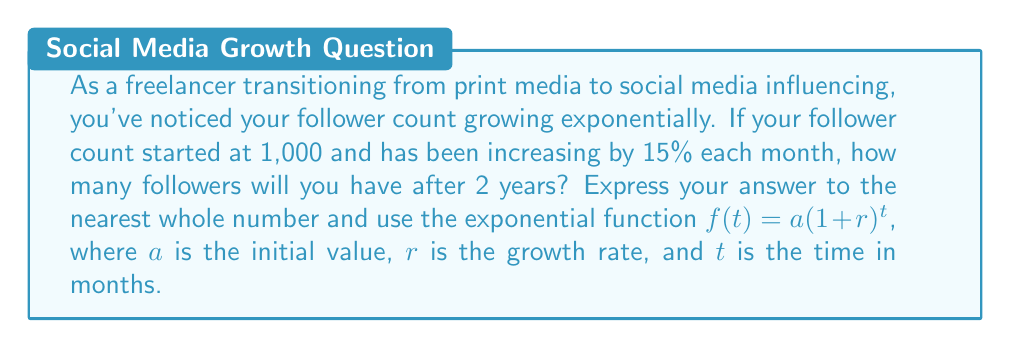Solve this math problem. Let's approach this step-by-step:

1) We're given:
   - Initial follower count, $a = 1,000$
   - Monthly growth rate, $r = 15\% = 0.15$
   - Time period, $t = 2$ years $= 24$ months

2) We'll use the exponential growth function:
   $f(t) = a(1+r)^t$

3) Substituting our values:
   $f(24) = 1000(1+0.15)^{24}$

4) Simplify inside the parentheses:
   $f(24) = 1000(1.15)^{24}$

5) Calculate $(1.15)^{24}$:
   $(1.15)^{24} \approx 31.772261...$

6) Multiply by 1000:
   $f(24) = 1000 * 31.772261... = 31,772.261...$

7) Rounding to the nearest whole number:
   $f(24) \approx 31,772$ followers
Answer: 31,772 followers 